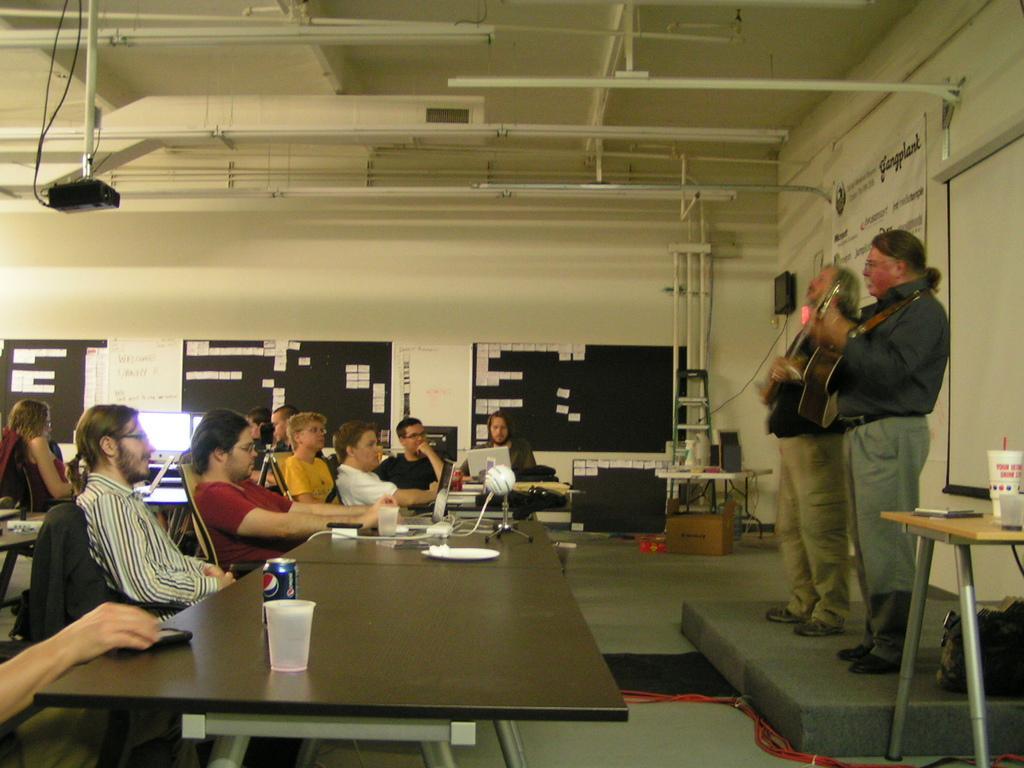Describe this image in one or two sentences. This is the picture of a hall where we have some people sitting on the chair in front of the tables on which there are some tins,glasses and bottles and beside them there is a board on which some papers past and there are some lights and two people standing on the dais in front of them and there is a stool and a white board. 